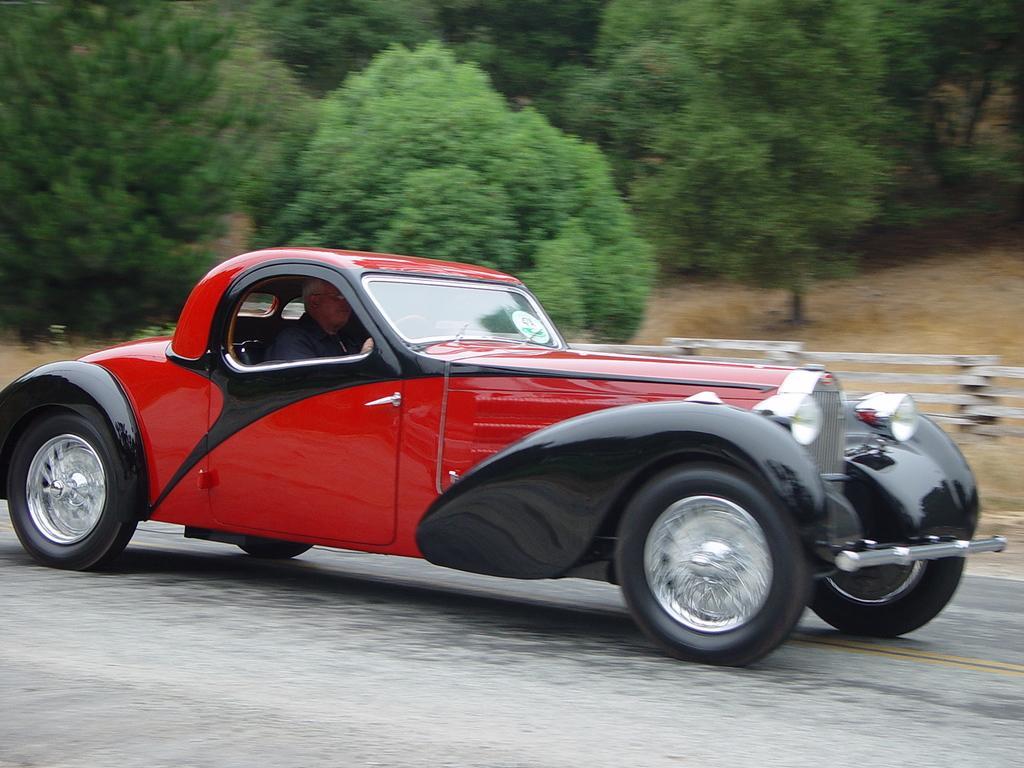In one or two sentences, can you explain what this image depicts? In the image we can see there is a car parked on the road and there is a person sitting in the car. Behind there are trees and there is a wooden pole fencing. 